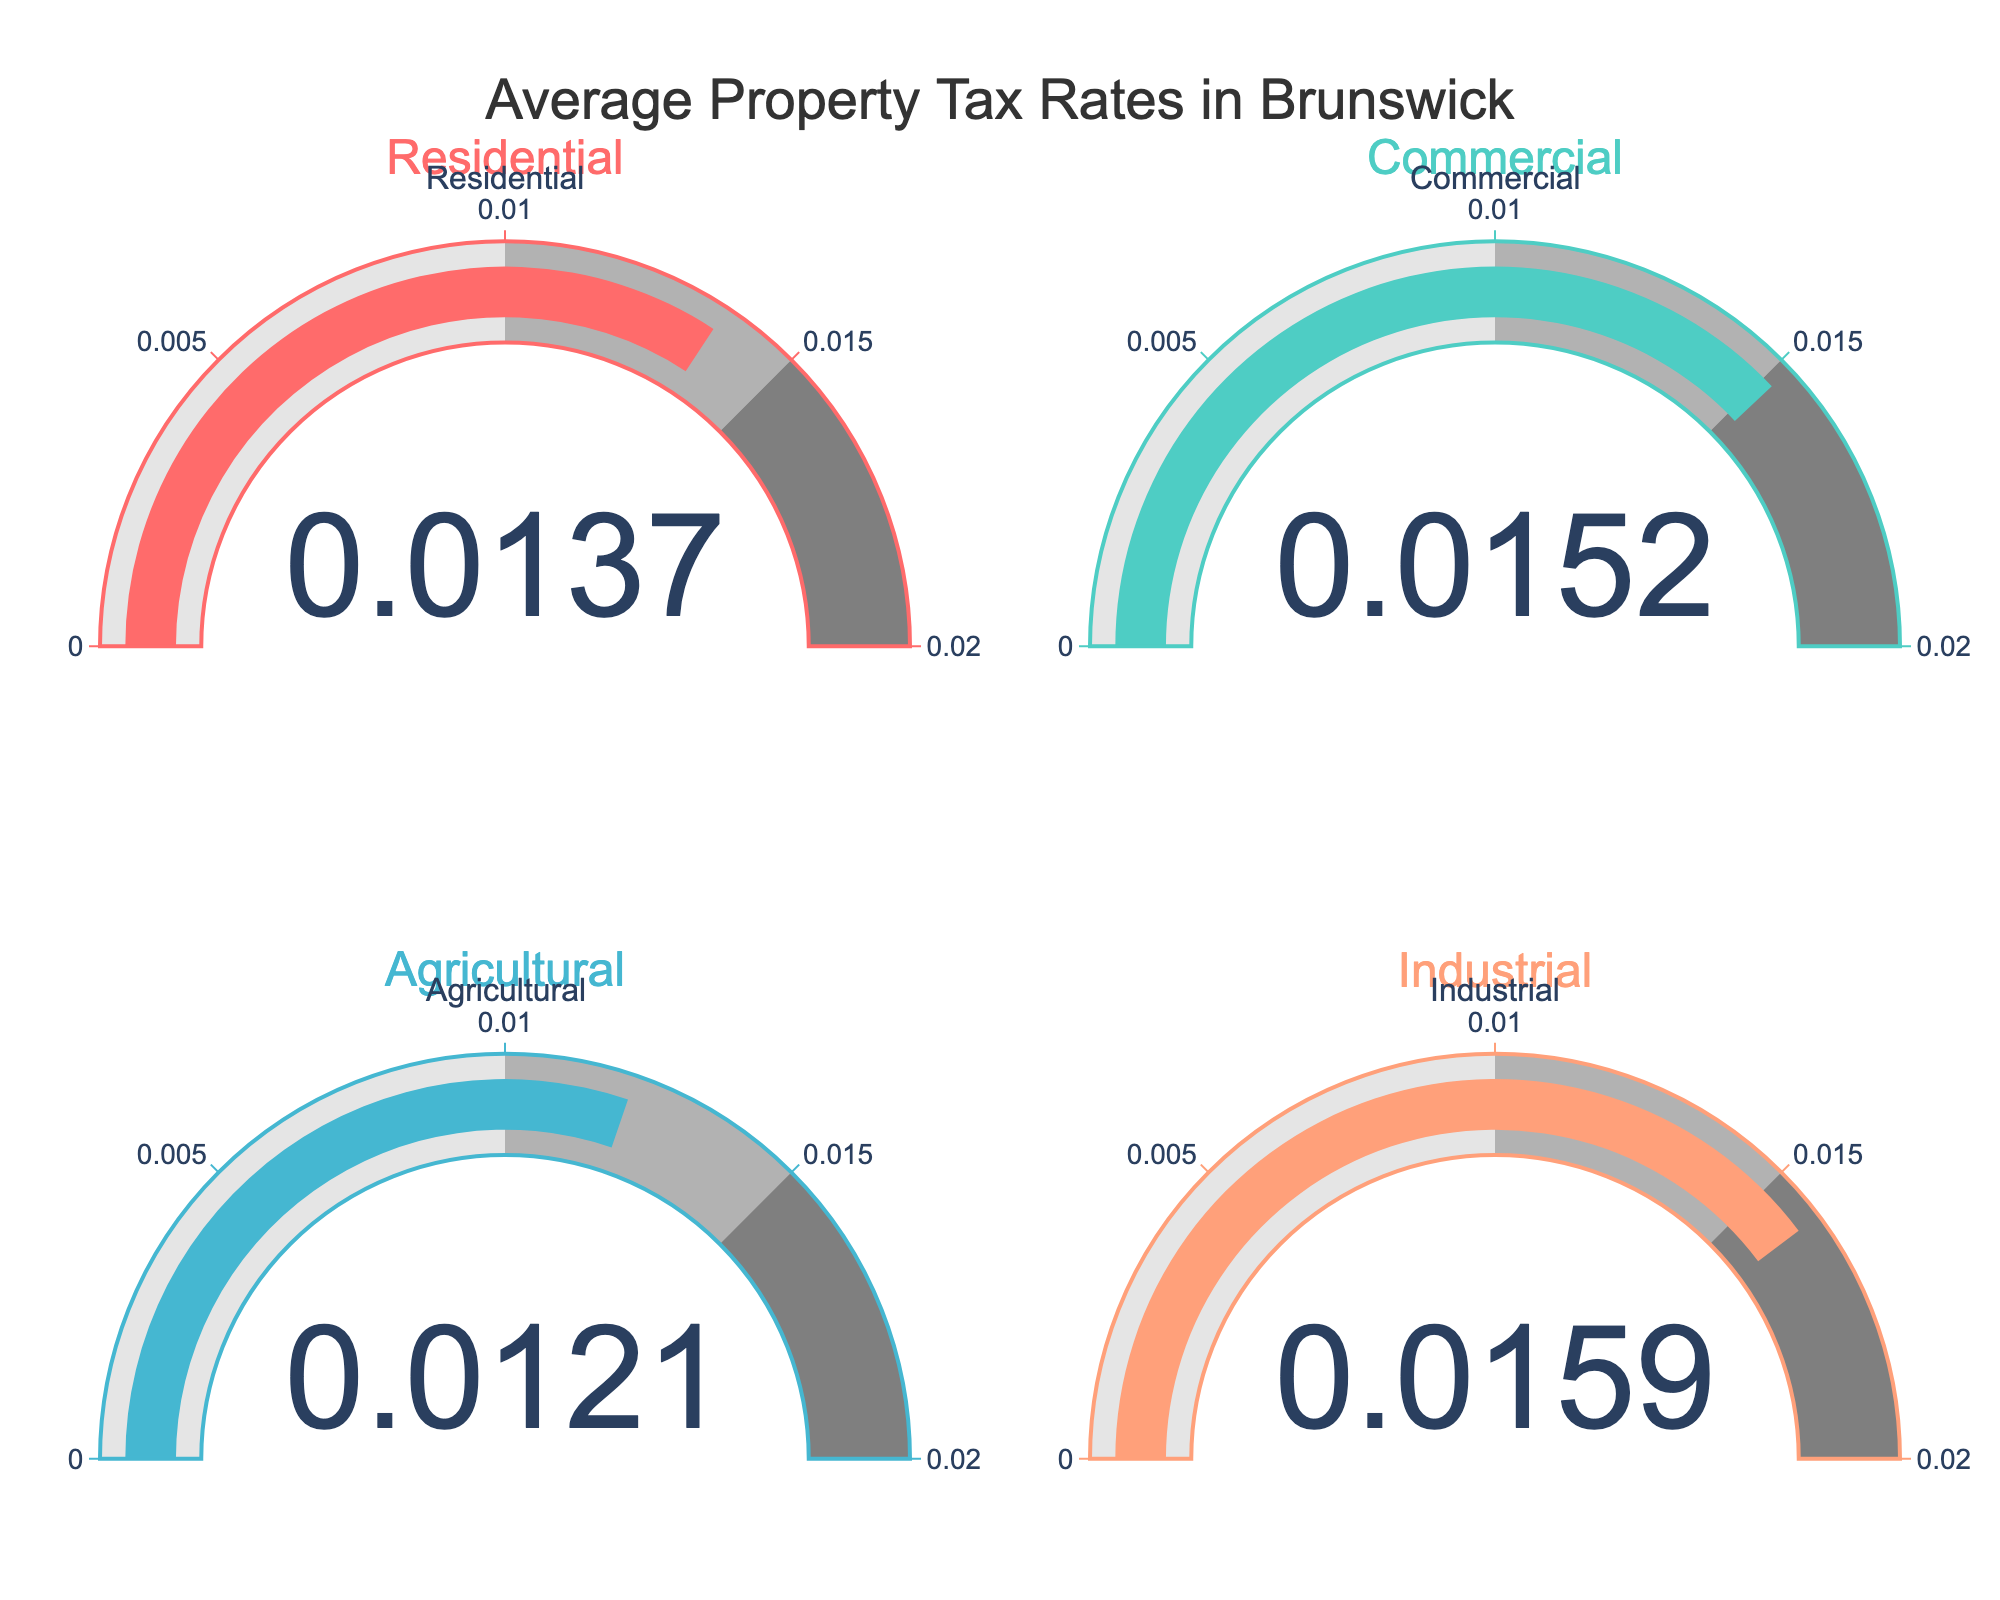What's the average property tax rate for all the property types? The property tax rates for each type are: Residential (0.0137), Commercial (0.0152), Agricultural (0.0121), Industrial (0.0159). The sum of these rates is 0.0137 + 0.0152 + 0.0121 + 0.0159 = 0.0569. The average is calculated as 0.0569 / 4 = 0.014225
Answer: 0.014225 Which property type has the highest tax rate? The tax rates for the property types are: Residential (0.0137), Commercial (0.0152), Agricultural (0.0121), and Industrial (0.0159). Among these, Industrial has the highest tax rate at 0.0159
Answer: Industrial Which property type has the lowest tax rate? The tax rates for the property types are: Residential (0.0137), Commercial (0.0152), Agricultural (0.0121), and Industrial (0.0159). The Agricultural property type has the lowest tax rate at 0.0121
Answer: Agricultural How much higher is the Commercial tax rate compared to the Residential tax rate? The Commercial tax rate is 0.0152 and the Residential tax rate is 0.0137. The difference is calculated as 0.0152 - 0.0137 = 0.0015
Answer: 0.0015 What is the range of property tax rates among these properties? The highest tax rate is for Industrial (0.0159) and the lowest is for Agricultural (0.0121). The range is calculated as 0.0159 - 0.0121 = 0.0038
Answer: 0.0038 By how much does the Industrial tax rate exceed the Agricultural tax rate? The Industrial tax rate is 0.0159 and the Agricultural tax rate is 0.0121. The difference is calculated as 0.0159 - 0.0121 = 0.0038
Answer: 0.0038 If you combine the tax rates for Residential and Agricultural properties, what would be the total? The Residential tax rate is 0.0137 and the Agricultural tax rate is 0.0121. The total combined rate is 0.0137 + 0.0121 = 0.0258
Answer: 0.0258 What is the difference in tax rates between Commercial and Industrial properties? The Commercial tax rate is 0.0152 and the Industrial tax rate is 0.0159. The difference is calculated as 0.0159 - 0.0152 = 0.0007
Answer: 0.0007 